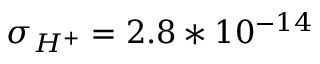Convert formula to latex. <formula><loc_0><loc_0><loc_500><loc_500>\sigma _ { H ^ { + } } = 2 . 8 * 1 0 ^ { - 1 4 }</formula> 